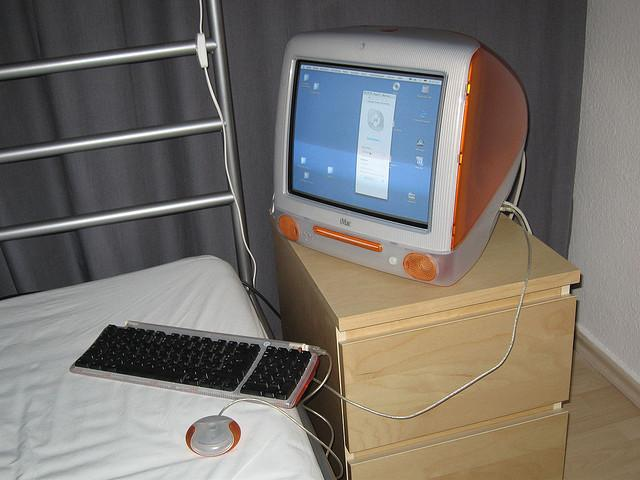What is sitting on the dresser?

Choices:
A) monitor
B) tablet
C) phone
D) kindle monitor 